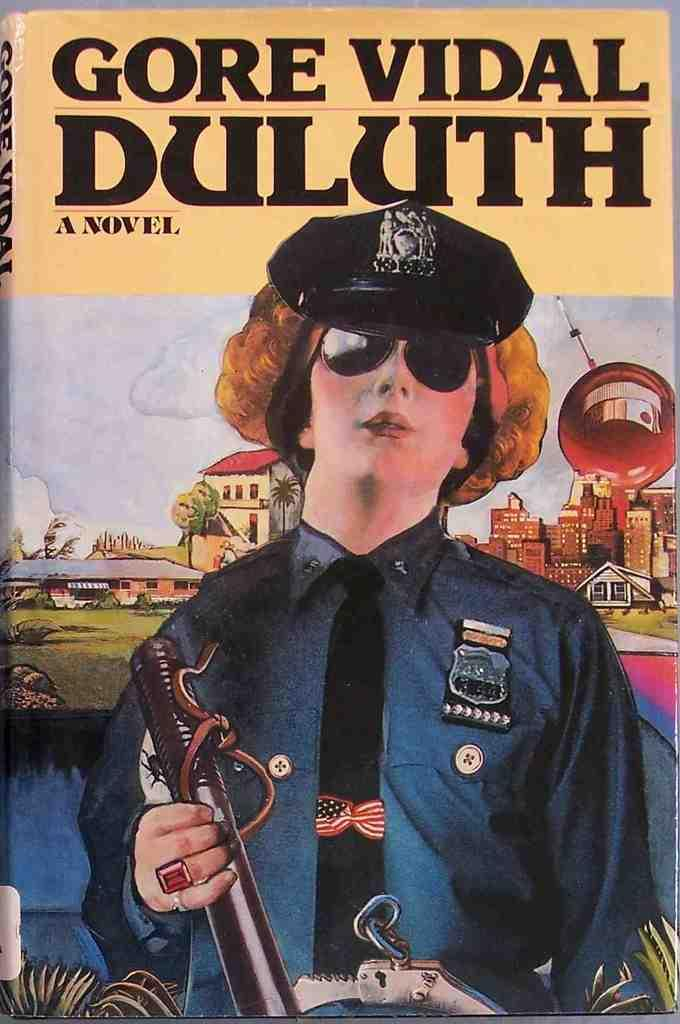What is the main subject of the image? There is a depiction of a person in the image. What type of structures can be seen in the image? There are houses in the image. What type of vegetation is present in the image? There are trees in the image. What part of the natural environment is visible in the image? The sky is visible in the image. Can you describe any other elements in the image? There are other unspecified things in the image. Is there any text or writing in the image? Yes, there is something written on the image. How many snakes are slithering on the trail in the image? There are no snakes or trails present in the image. What type of cast is visible on the person's arm in the image? There is no cast visible on the person's arm in the image. 